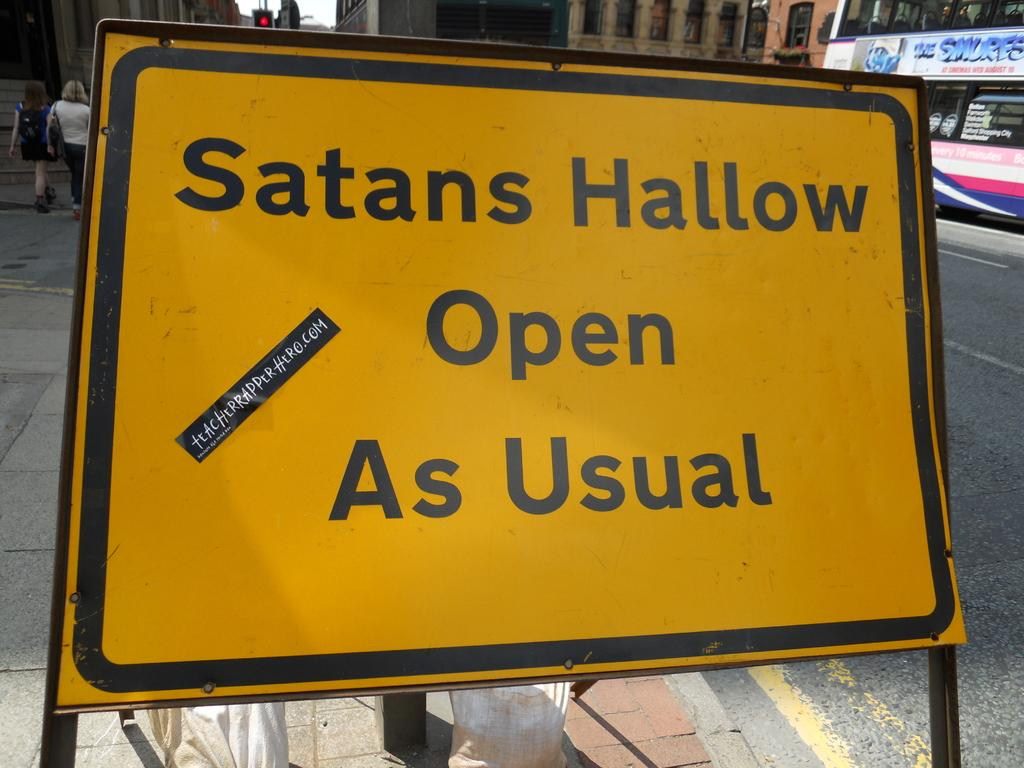<image>
Give a short and clear explanation of the subsequent image. a yellow sign says Satans Hallow open as usual 